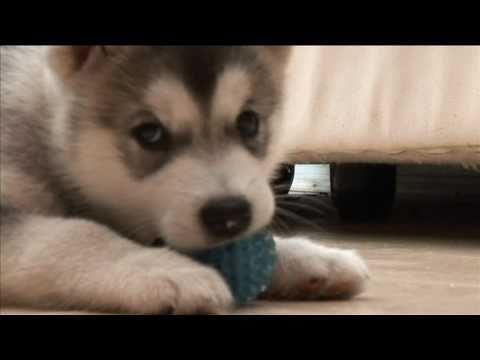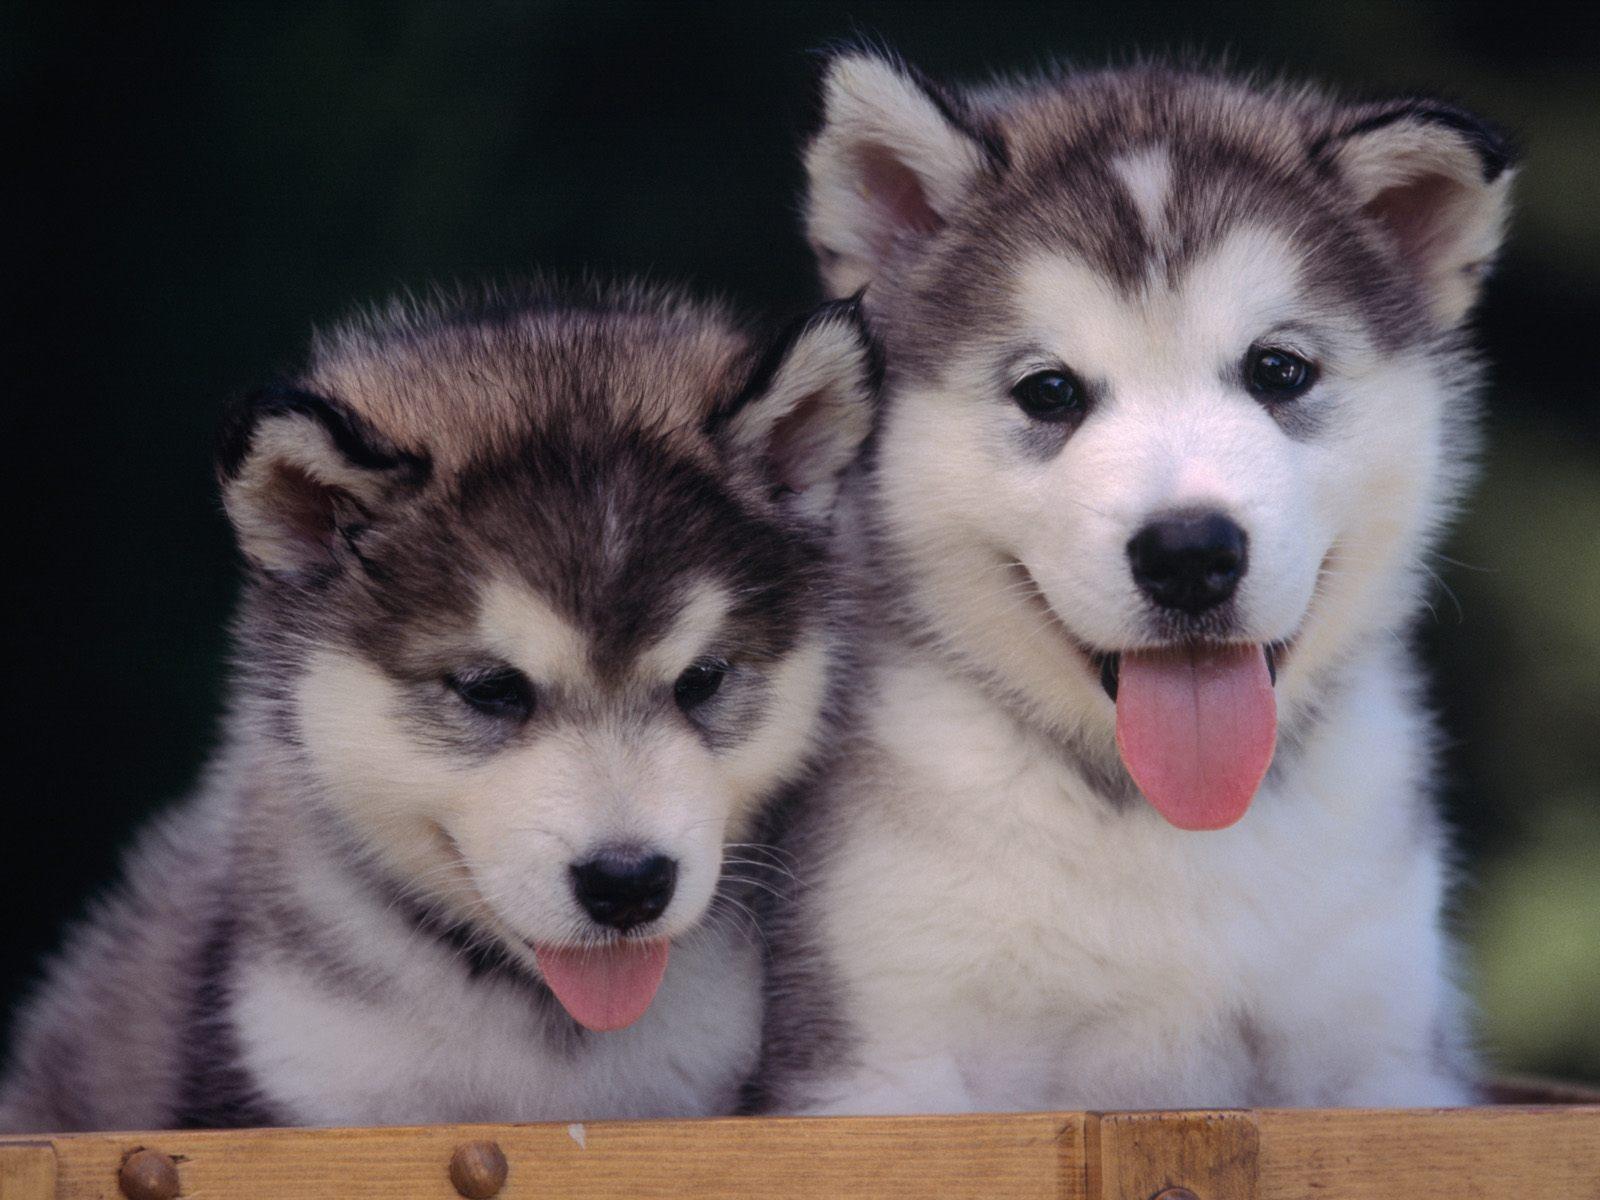The first image is the image on the left, the second image is the image on the right. Analyze the images presented: Is the assertion "Exactly two dogs have their tongues out." valid? Answer yes or no. Yes. 